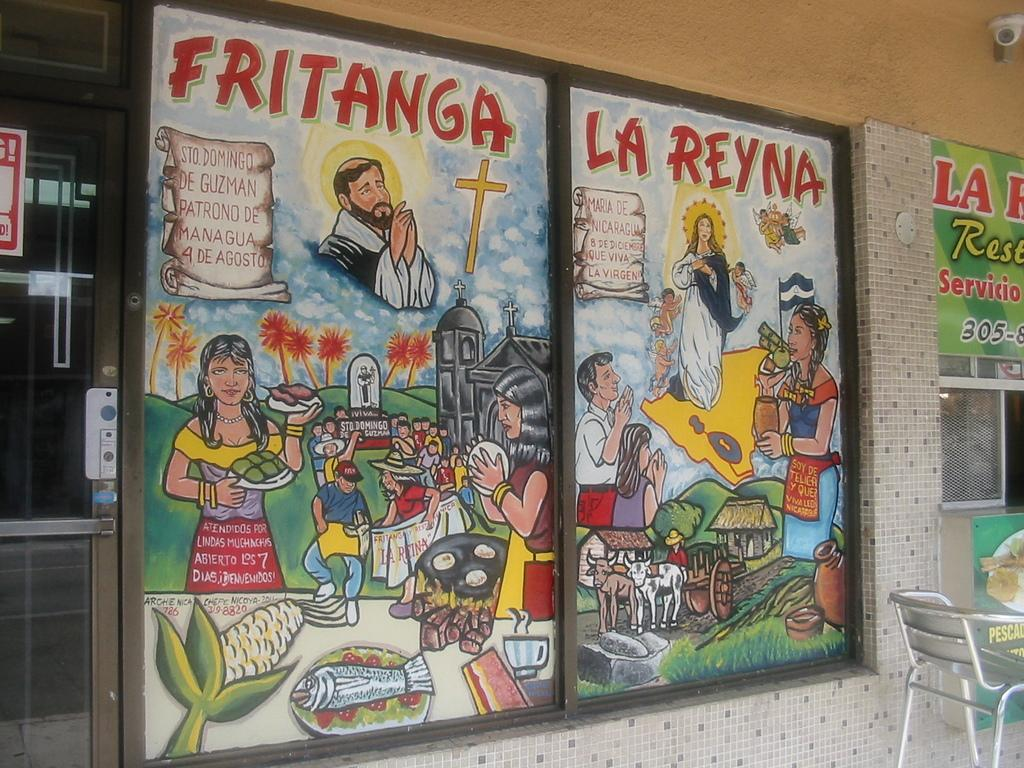<image>
Share a concise interpretation of the image provided. Artwork that says, "Fritanga, La Reyna" is posted on a window. 